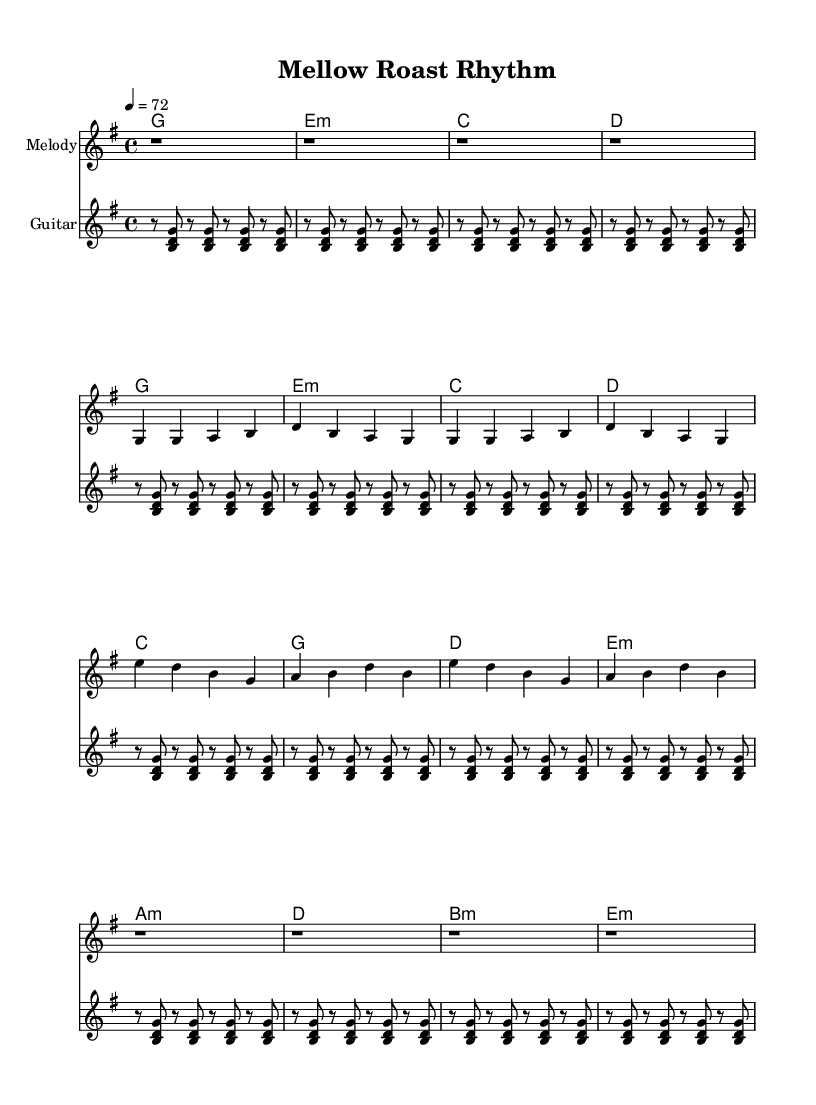What is the key signature of this music? The key signature is G major, which has one sharp (F#).
Answer: G major What is the time signature of this music? The time signature is 4/4, indicating four beats per measure.
Answer: 4/4 What is the tempo marking for this tune? The tempo marking is 72 beats per minute, indicated by the notation "4 = 72".
Answer: 72 How many measures are in the verse section? The verse section consists of 4 measures, as indicated by the repetition in the melody notation.
Answer: 4 In which measure does the chorus begin? The chorus begins in measure 9, following the verse section.
Answer: Measure 9 What type of guitar is specified for the melody? The music indicates an electric guitar with a clean tone for the melody section.
Answer: Electric guitar What is a characteristic feature of reggae rhythms present in this sheet music? The rhythmic pattern includes syncopation, typical in reggae music, demonstrated by the guitar rhythm and melody.
Answer: Syncopation 